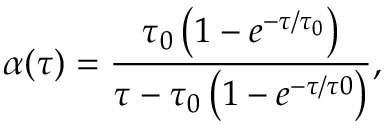<formula> <loc_0><loc_0><loc_500><loc_500>\alpha ( \tau ) = \frac { \tau _ { 0 } \left ( 1 - e ^ { - \tau / \tau _ { 0 } } \right ) } { \tau - \tau _ { 0 } \left ( 1 - e ^ { - \tau / \tau 0 } \right ) } ,</formula> 